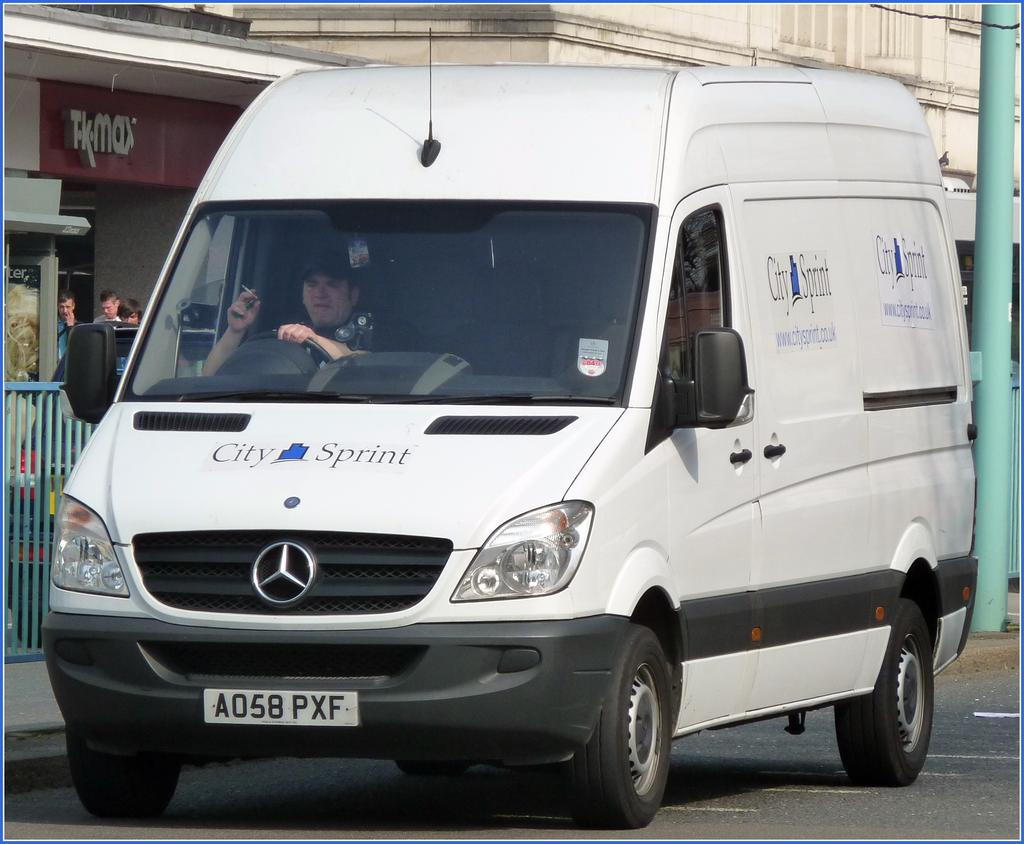<image>
Relay a brief, clear account of the picture shown. A white van that says City of Sprint on it. 